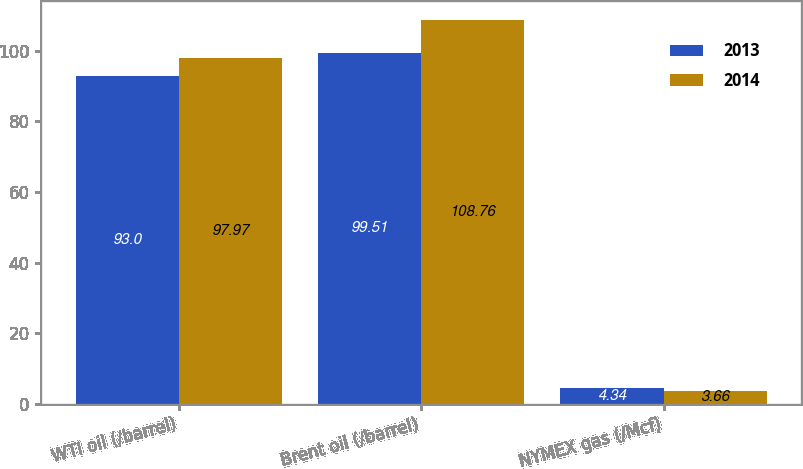Convert chart. <chart><loc_0><loc_0><loc_500><loc_500><stacked_bar_chart><ecel><fcel>WTI oil (/barrel)<fcel>Brent oil (/barrel)<fcel>NYMEX gas (/Mcf)<nl><fcel>2013<fcel>93<fcel>99.51<fcel>4.34<nl><fcel>2014<fcel>97.97<fcel>108.76<fcel>3.66<nl></chart> 